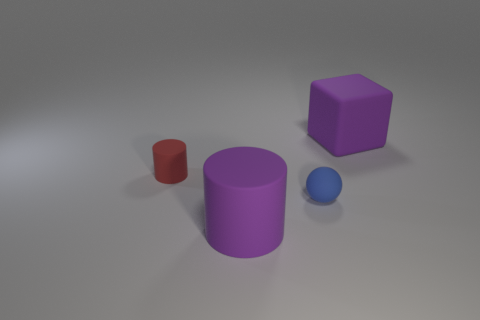What is the color of the rubber sphere that is the same size as the red cylinder?
Keep it short and to the point. Blue. There is a large matte thing that is behind the large purple object that is in front of the small blue matte sphere; is there a small matte thing that is in front of it?
Ensure brevity in your answer.  Yes. Do the tiny blue rubber object and the big purple thing that is in front of the tiny red rubber thing have the same shape?
Keep it short and to the point. No. Are there the same number of tiny cylinders to the left of the ball and tiny things that are behind the tiny red rubber cylinder?
Offer a terse response. No. How many other objects are there of the same material as the big purple cylinder?
Your answer should be very brief. 3. What number of rubber things are small balls or purple things?
Your answer should be compact. 3. There is a purple rubber object that is behind the tiny cylinder; is its shape the same as the blue rubber object?
Provide a short and direct response. No. Are there more blue rubber balls to the left of the small matte sphere than tiny green spheres?
Make the answer very short. No. What number of big purple rubber things are both in front of the small matte cylinder and on the right side of the large purple cylinder?
Your answer should be very brief. 0. There is a rubber thing to the right of the small thing that is on the right side of the tiny red rubber cylinder; what color is it?
Provide a succinct answer. Purple. 